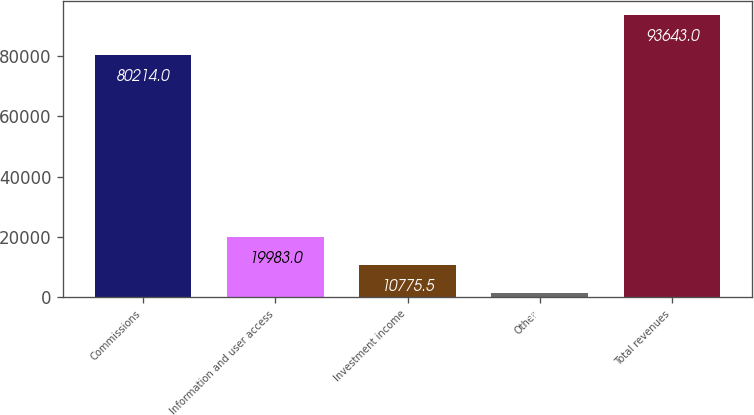Convert chart. <chart><loc_0><loc_0><loc_500><loc_500><bar_chart><fcel>Commissions<fcel>Information and user access<fcel>Investment income<fcel>Other<fcel>Total revenues<nl><fcel>80214<fcel>19983<fcel>10775.5<fcel>1568<fcel>93643<nl></chart> 